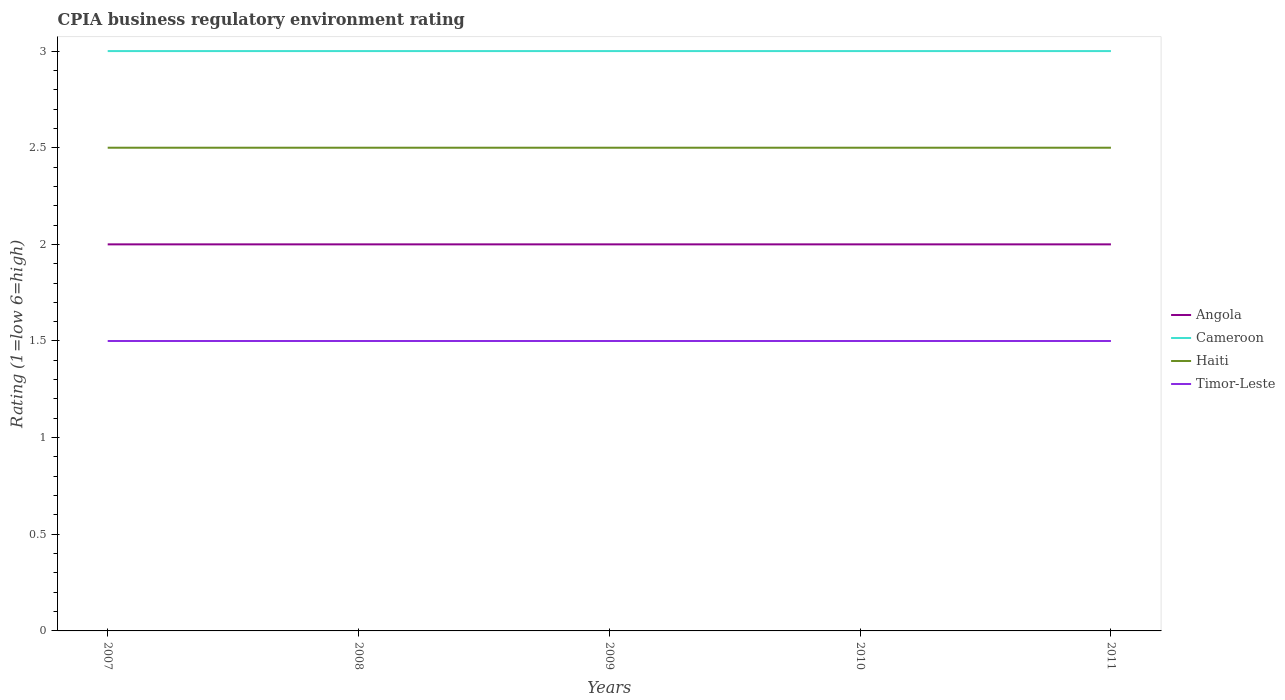Does the line corresponding to Haiti intersect with the line corresponding to Cameroon?
Your response must be concise. No. What is the total CPIA rating in Cameroon in the graph?
Keep it short and to the point. 0. What is the difference between the highest and the second highest CPIA rating in Cameroon?
Your answer should be very brief. 0. How many lines are there?
Keep it short and to the point. 4. How many years are there in the graph?
Offer a terse response. 5. Are the values on the major ticks of Y-axis written in scientific E-notation?
Ensure brevity in your answer.  No. Does the graph contain any zero values?
Ensure brevity in your answer.  No. Does the graph contain grids?
Offer a very short reply. No. Where does the legend appear in the graph?
Offer a very short reply. Center right. How many legend labels are there?
Offer a very short reply. 4. What is the title of the graph?
Keep it short and to the point. CPIA business regulatory environment rating. Does "Austria" appear as one of the legend labels in the graph?
Offer a very short reply. No. What is the Rating (1=low 6=high) in Cameroon in 2007?
Your answer should be compact. 3. What is the Rating (1=low 6=high) of Angola in 2008?
Offer a very short reply. 2. What is the Rating (1=low 6=high) in Cameroon in 2008?
Provide a short and direct response. 3. What is the Rating (1=low 6=high) of Cameroon in 2009?
Give a very brief answer. 3. What is the Rating (1=low 6=high) in Timor-Leste in 2009?
Offer a very short reply. 1.5. What is the Rating (1=low 6=high) of Cameroon in 2010?
Your response must be concise. 3. What is the Rating (1=low 6=high) of Timor-Leste in 2010?
Give a very brief answer. 1.5. What is the Rating (1=low 6=high) of Cameroon in 2011?
Provide a succinct answer. 3. What is the Rating (1=low 6=high) in Timor-Leste in 2011?
Ensure brevity in your answer.  1.5. Across all years, what is the maximum Rating (1=low 6=high) of Haiti?
Provide a short and direct response. 2.5. Across all years, what is the maximum Rating (1=low 6=high) in Timor-Leste?
Provide a succinct answer. 1.5. Across all years, what is the minimum Rating (1=low 6=high) in Cameroon?
Provide a short and direct response. 3. Across all years, what is the minimum Rating (1=low 6=high) in Haiti?
Provide a short and direct response. 2.5. Across all years, what is the minimum Rating (1=low 6=high) in Timor-Leste?
Your answer should be very brief. 1.5. What is the total Rating (1=low 6=high) in Angola in the graph?
Provide a short and direct response. 10. What is the total Rating (1=low 6=high) in Timor-Leste in the graph?
Ensure brevity in your answer.  7.5. What is the difference between the Rating (1=low 6=high) of Angola in 2007 and that in 2008?
Provide a short and direct response. 0. What is the difference between the Rating (1=low 6=high) of Cameroon in 2007 and that in 2008?
Your answer should be compact. 0. What is the difference between the Rating (1=low 6=high) in Timor-Leste in 2007 and that in 2008?
Your answer should be very brief. 0. What is the difference between the Rating (1=low 6=high) of Angola in 2007 and that in 2009?
Your answer should be compact. 0. What is the difference between the Rating (1=low 6=high) of Cameroon in 2007 and that in 2009?
Provide a succinct answer. 0. What is the difference between the Rating (1=low 6=high) in Haiti in 2007 and that in 2009?
Keep it short and to the point. 0. What is the difference between the Rating (1=low 6=high) in Timor-Leste in 2007 and that in 2009?
Provide a short and direct response. 0. What is the difference between the Rating (1=low 6=high) in Cameroon in 2007 and that in 2010?
Your response must be concise. 0. What is the difference between the Rating (1=low 6=high) of Timor-Leste in 2007 and that in 2011?
Offer a very short reply. 0. What is the difference between the Rating (1=low 6=high) in Timor-Leste in 2008 and that in 2009?
Provide a succinct answer. 0. What is the difference between the Rating (1=low 6=high) of Angola in 2008 and that in 2010?
Make the answer very short. 0. What is the difference between the Rating (1=low 6=high) in Haiti in 2008 and that in 2010?
Provide a succinct answer. 0. What is the difference between the Rating (1=low 6=high) of Timor-Leste in 2008 and that in 2010?
Your answer should be compact. 0. What is the difference between the Rating (1=low 6=high) in Cameroon in 2008 and that in 2011?
Provide a short and direct response. 0. What is the difference between the Rating (1=low 6=high) of Haiti in 2008 and that in 2011?
Your answer should be very brief. 0. What is the difference between the Rating (1=low 6=high) of Cameroon in 2009 and that in 2010?
Your answer should be compact. 0. What is the difference between the Rating (1=low 6=high) in Angola in 2010 and that in 2011?
Give a very brief answer. 0. What is the difference between the Rating (1=low 6=high) of Cameroon in 2010 and that in 2011?
Ensure brevity in your answer.  0. What is the difference between the Rating (1=low 6=high) in Angola in 2007 and the Rating (1=low 6=high) in Cameroon in 2008?
Offer a terse response. -1. What is the difference between the Rating (1=low 6=high) in Haiti in 2007 and the Rating (1=low 6=high) in Timor-Leste in 2008?
Ensure brevity in your answer.  1. What is the difference between the Rating (1=low 6=high) of Angola in 2007 and the Rating (1=low 6=high) of Haiti in 2009?
Give a very brief answer. -0.5. What is the difference between the Rating (1=low 6=high) in Angola in 2007 and the Rating (1=low 6=high) in Timor-Leste in 2009?
Give a very brief answer. 0.5. What is the difference between the Rating (1=low 6=high) in Cameroon in 2007 and the Rating (1=low 6=high) in Haiti in 2009?
Your answer should be compact. 0.5. What is the difference between the Rating (1=low 6=high) in Cameroon in 2007 and the Rating (1=low 6=high) in Timor-Leste in 2009?
Keep it short and to the point. 1.5. What is the difference between the Rating (1=low 6=high) of Haiti in 2007 and the Rating (1=low 6=high) of Timor-Leste in 2009?
Give a very brief answer. 1. What is the difference between the Rating (1=low 6=high) in Angola in 2007 and the Rating (1=low 6=high) in Cameroon in 2010?
Ensure brevity in your answer.  -1. What is the difference between the Rating (1=low 6=high) of Angola in 2007 and the Rating (1=low 6=high) of Timor-Leste in 2010?
Your answer should be compact. 0.5. What is the difference between the Rating (1=low 6=high) in Cameroon in 2007 and the Rating (1=low 6=high) in Haiti in 2010?
Offer a very short reply. 0.5. What is the difference between the Rating (1=low 6=high) of Haiti in 2007 and the Rating (1=low 6=high) of Timor-Leste in 2010?
Provide a succinct answer. 1. What is the difference between the Rating (1=low 6=high) of Cameroon in 2007 and the Rating (1=low 6=high) of Haiti in 2011?
Offer a terse response. 0.5. What is the difference between the Rating (1=low 6=high) of Cameroon in 2007 and the Rating (1=low 6=high) of Timor-Leste in 2011?
Provide a short and direct response. 1.5. What is the difference between the Rating (1=low 6=high) of Haiti in 2007 and the Rating (1=low 6=high) of Timor-Leste in 2011?
Provide a short and direct response. 1. What is the difference between the Rating (1=low 6=high) in Angola in 2008 and the Rating (1=low 6=high) in Cameroon in 2009?
Your response must be concise. -1. What is the difference between the Rating (1=low 6=high) in Cameroon in 2008 and the Rating (1=low 6=high) in Haiti in 2009?
Offer a very short reply. 0.5. What is the difference between the Rating (1=low 6=high) in Haiti in 2008 and the Rating (1=low 6=high) in Timor-Leste in 2009?
Provide a short and direct response. 1. What is the difference between the Rating (1=low 6=high) in Angola in 2008 and the Rating (1=low 6=high) in Cameroon in 2010?
Give a very brief answer. -1. What is the difference between the Rating (1=low 6=high) in Angola in 2008 and the Rating (1=low 6=high) in Haiti in 2010?
Offer a very short reply. -0.5. What is the difference between the Rating (1=low 6=high) of Cameroon in 2008 and the Rating (1=low 6=high) of Timor-Leste in 2010?
Keep it short and to the point. 1.5. What is the difference between the Rating (1=low 6=high) in Cameroon in 2008 and the Rating (1=low 6=high) in Timor-Leste in 2011?
Ensure brevity in your answer.  1.5. What is the difference between the Rating (1=low 6=high) of Angola in 2009 and the Rating (1=low 6=high) of Cameroon in 2010?
Give a very brief answer. -1. What is the difference between the Rating (1=low 6=high) in Angola in 2009 and the Rating (1=low 6=high) in Haiti in 2010?
Your response must be concise. -0.5. What is the difference between the Rating (1=low 6=high) of Angola in 2009 and the Rating (1=low 6=high) of Timor-Leste in 2010?
Make the answer very short. 0.5. What is the difference between the Rating (1=low 6=high) of Cameroon in 2009 and the Rating (1=low 6=high) of Haiti in 2010?
Offer a very short reply. 0.5. What is the difference between the Rating (1=low 6=high) in Haiti in 2009 and the Rating (1=low 6=high) in Timor-Leste in 2010?
Offer a very short reply. 1. What is the difference between the Rating (1=low 6=high) in Angola in 2009 and the Rating (1=low 6=high) in Cameroon in 2011?
Make the answer very short. -1. What is the difference between the Rating (1=low 6=high) in Cameroon in 2009 and the Rating (1=low 6=high) in Timor-Leste in 2011?
Make the answer very short. 1.5. What is the difference between the Rating (1=low 6=high) in Angola in 2010 and the Rating (1=low 6=high) in Cameroon in 2011?
Provide a short and direct response. -1. What is the difference between the Rating (1=low 6=high) of Cameroon in 2010 and the Rating (1=low 6=high) of Haiti in 2011?
Your answer should be compact. 0.5. What is the difference between the Rating (1=low 6=high) of Cameroon in 2010 and the Rating (1=low 6=high) of Timor-Leste in 2011?
Offer a very short reply. 1.5. What is the difference between the Rating (1=low 6=high) in Haiti in 2010 and the Rating (1=low 6=high) in Timor-Leste in 2011?
Offer a terse response. 1. What is the average Rating (1=low 6=high) in Angola per year?
Offer a terse response. 2. In the year 2007, what is the difference between the Rating (1=low 6=high) of Angola and Rating (1=low 6=high) of Haiti?
Provide a succinct answer. -0.5. In the year 2007, what is the difference between the Rating (1=low 6=high) of Angola and Rating (1=low 6=high) of Timor-Leste?
Make the answer very short. 0.5. In the year 2007, what is the difference between the Rating (1=low 6=high) of Haiti and Rating (1=low 6=high) of Timor-Leste?
Offer a terse response. 1. In the year 2008, what is the difference between the Rating (1=low 6=high) of Angola and Rating (1=low 6=high) of Cameroon?
Keep it short and to the point. -1. In the year 2008, what is the difference between the Rating (1=low 6=high) in Angola and Rating (1=low 6=high) in Timor-Leste?
Keep it short and to the point. 0.5. In the year 2008, what is the difference between the Rating (1=low 6=high) of Cameroon and Rating (1=low 6=high) of Haiti?
Offer a very short reply. 0.5. In the year 2008, what is the difference between the Rating (1=low 6=high) in Haiti and Rating (1=low 6=high) in Timor-Leste?
Provide a succinct answer. 1. In the year 2009, what is the difference between the Rating (1=low 6=high) of Angola and Rating (1=low 6=high) of Cameroon?
Make the answer very short. -1. In the year 2009, what is the difference between the Rating (1=low 6=high) of Angola and Rating (1=low 6=high) of Timor-Leste?
Provide a short and direct response. 0.5. In the year 2009, what is the difference between the Rating (1=low 6=high) in Cameroon and Rating (1=low 6=high) in Haiti?
Give a very brief answer. 0.5. In the year 2009, what is the difference between the Rating (1=low 6=high) of Cameroon and Rating (1=low 6=high) of Timor-Leste?
Offer a very short reply. 1.5. In the year 2009, what is the difference between the Rating (1=low 6=high) of Haiti and Rating (1=low 6=high) of Timor-Leste?
Your answer should be compact. 1. In the year 2010, what is the difference between the Rating (1=low 6=high) in Angola and Rating (1=low 6=high) in Haiti?
Make the answer very short. -0.5. In the year 2010, what is the difference between the Rating (1=low 6=high) of Cameroon and Rating (1=low 6=high) of Haiti?
Give a very brief answer. 0.5. In the year 2010, what is the difference between the Rating (1=low 6=high) of Haiti and Rating (1=low 6=high) of Timor-Leste?
Provide a short and direct response. 1. In the year 2011, what is the difference between the Rating (1=low 6=high) in Angola and Rating (1=low 6=high) in Cameroon?
Make the answer very short. -1. What is the ratio of the Rating (1=low 6=high) of Angola in 2007 to that in 2008?
Ensure brevity in your answer.  1. What is the ratio of the Rating (1=low 6=high) in Cameroon in 2007 to that in 2009?
Ensure brevity in your answer.  1. What is the ratio of the Rating (1=low 6=high) of Haiti in 2007 to that in 2009?
Provide a short and direct response. 1. What is the ratio of the Rating (1=low 6=high) in Timor-Leste in 2007 to that in 2009?
Ensure brevity in your answer.  1. What is the ratio of the Rating (1=low 6=high) of Cameroon in 2007 to that in 2010?
Offer a terse response. 1. What is the ratio of the Rating (1=low 6=high) of Timor-Leste in 2007 to that in 2010?
Offer a very short reply. 1. What is the ratio of the Rating (1=low 6=high) in Timor-Leste in 2007 to that in 2011?
Give a very brief answer. 1. What is the ratio of the Rating (1=low 6=high) in Haiti in 2008 to that in 2009?
Your answer should be very brief. 1. What is the ratio of the Rating (1=low 6=high) in Timor-Leste in 2008 to that in 2009?
Make the answer very short. 1. What is the ratio of the Rating (1=low 6=high) of Angola in 2008 to that in 2010?
Your answer should be very brief. 1. What is the ratio of the Rating (1=low 6=high) in Haiti in 2008 to that in 2010?
Ensure brevity in your answer.  1. What is the ratio of the Rating (1=low 6=high) in Cameroon in 2008 to that in 2011?
Your answer should be compact. 1. What is the ratio of the Rating (1=low 6=high) in Timor-Leste in 2008 to that in 2011?
Offer a very short reply. 1. What is the ratio of the Rating (1=low 6=high) in Angola in 2009 to that in 2010?
Give a very brief answer. 1. What is the ratio of the Rating (1=low 6=high) of Timor-Leste in 2009 to that in 2010?
Your response must be concise. 1. What is the ratio of the Rating (1=low 6=high) of Cameroon in 2009 to that in 2011?
Give a very brief answer. 1. What is the ratio of the Rating (1=low 6=high) of Haiti in 2009 to that in 2011?
Keep it short and to the point. 1. What is the ratio of the Rating (1=low 6=high) of Angola in 2010 to that in 2011?
Give a very brief answer. 1. What is the ratio of the Rating (1=low 6=high) in Cameroon in 2010 to that in 2011?
Ensure brevity in your answer.  1. What is the difference between the highest and the second highest Rating (1=low 6=high) in Angola?
Your response must be concise. 0. What is the difference between the highest and the second highest Rating (1=low 6=high) of Haiti?
Your answer should be compact. 0. What is the difference between the highest and the second highest Rating (1=low 6=high) in Timor-Leste?
Your answer should be compact. 0. What is the difference between the highest and the lowest Rating (1=low 6=high) of Angola?
Your response must be concise. 0. What is the difference between the highest and the lowest Rating (1=low 6=high) of Haiti?
Keep it short and to the point. 0. 